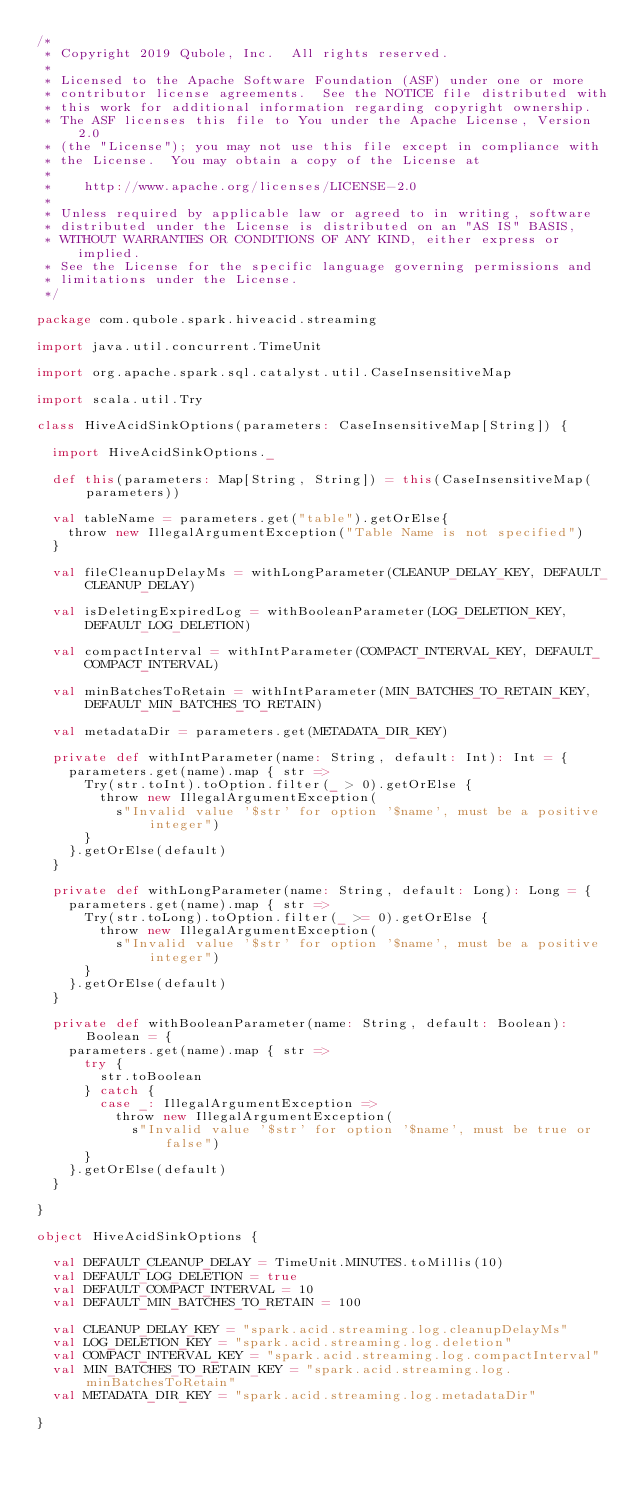Convert code to text. <code><loc_0><loc_0><loc_500><loc_500><_Scala_>/*
 * Copyright 2019 Qubole, Inc.  All rights reserved.
 *
 * Licensed to the Apache Software Foundation (ASF) under one or more
 * contributor license agreements.  See the NOTICE file distributed with
 * this work for additional information regarding copyright ownership.
 * The ASF licenses this file to You under the Apache License, Version 2.0
 * (the "License"); you may not use this file except in compliance with
 * the License.  You may obtain a copy of the License at
 *
 *    http://www.apache.org/licenses/LICENSE-2.0
 *
 * Unless required by applicable law or agreed to in writing, software
 * distributed under the License is distributed on an "AS IS" BASIS,
 * WITHOUT WARRANTIES OR CONDITIONS OF ANY KIND, either express or implied.
 * See the License for the specific language governing permissions and
 * limitations under the License.
 */

package com.qubole.spark.hiveacid.streaming

import java.util.concurrent.TimeUnit

import org.apache.spark.sql.catalyst.util.CaseInsensitiveMap

import scala.util.Try

class HiveAcidSinkOptions(parameters: CaseInsensitiveMap[String]) {

  import HiveAcidSinkOptions._

  def this(parameters: Map[String, String]) = this(CaseInsensitiveMap(parameters))

  val tableName = parameters.get("table").getOrElse{
    throw new IllegalArgumentException("Table Name is not specified")
  }

  val fileCleanupDelayMs = withLongParameter(CLEANUP_DELAY_KEY, DEFAULT_CLEANUP_DELAY)

  val isDeletingExpiredLog = withBooleanParameter(LOG_DELETION_KEY, DEFAULT_LOG_DELETION)

  val compactInterval = withIntParameter(COMPACT_INTERVAL_KEY, DEFAULT_COMPACT_INTERVAL)

  val minBatchesToRetain = withIntParameter(MIN_BATCHES_TO_RETAIN_KEY, DEFAULT_MIN_BATCHES_TO_RETAIN)

  val metadataDir = parameters.get(METADATA_DIR_KEY)

  private def withIntParameter(name: String, default: Int): Int = {
    parameters.get(name).map { str =>
      Try(str.toInt).toOption.filter(_ > 0).getOrElse {
        throw new IllegalArgumentException(
          s"Invalid value '$str' for option '$name', must be a positive integer")
      }
    }.getOrElse(default)
  }

  private def withLongParameter(name: String, default: Long): Long = {
    parameters.get(name).map { str =>
      Try(str.toLong).toOption.filter(_ >= 0).getOrElse {
        throw new IllegalArgumentException(
          s"Invalid value '$str' for option '$name', must be a positive integer")
      }
    }.getOrElse(default)
  }

  private def withBooleanParameter(name: String, default: Boolean): Boolean = {
    parameters.get(name).map { str =>
      try {
        str.toBoolean
      } catch {
        case _: IllegalArgumentException =>
          throw new IllegalArgumentException(
            s"Invalid value '$str' for option '$name', must be true or false")
      }
    }.getOrElse(default)
  }

}

object HiveAcidSinkOptions {

  val DEFAULT_CLEANUP_DELAY = TimeUnit.MINUTES.toMillis(10)
  val DEFAULT_LOG_DELETION = true
  val DEFAULT_COMPACT_INTERVAL = 10
  val DEFAULT_MIN_BATCHES_TO_RETAIN = 100

  val CLEANUP_DELAY_KEY = "spark.acid.streaming.log.cleanupDelayMs"
  val LOG_DELETION_KEY = "spark.acid.streaming.log.deletion"
  val COMPACT_INTERVAL_KEY = "spark.acid.streaming.log.compactInterval"
  val MIN_BATCHES_TO_RETAIN_KEY = "spark.acid.streaming.log.minBatchesToRetain"
  val METADATA_DIR_KEY = "spark.acid.streaming.log.metadataDir"

}</code> 